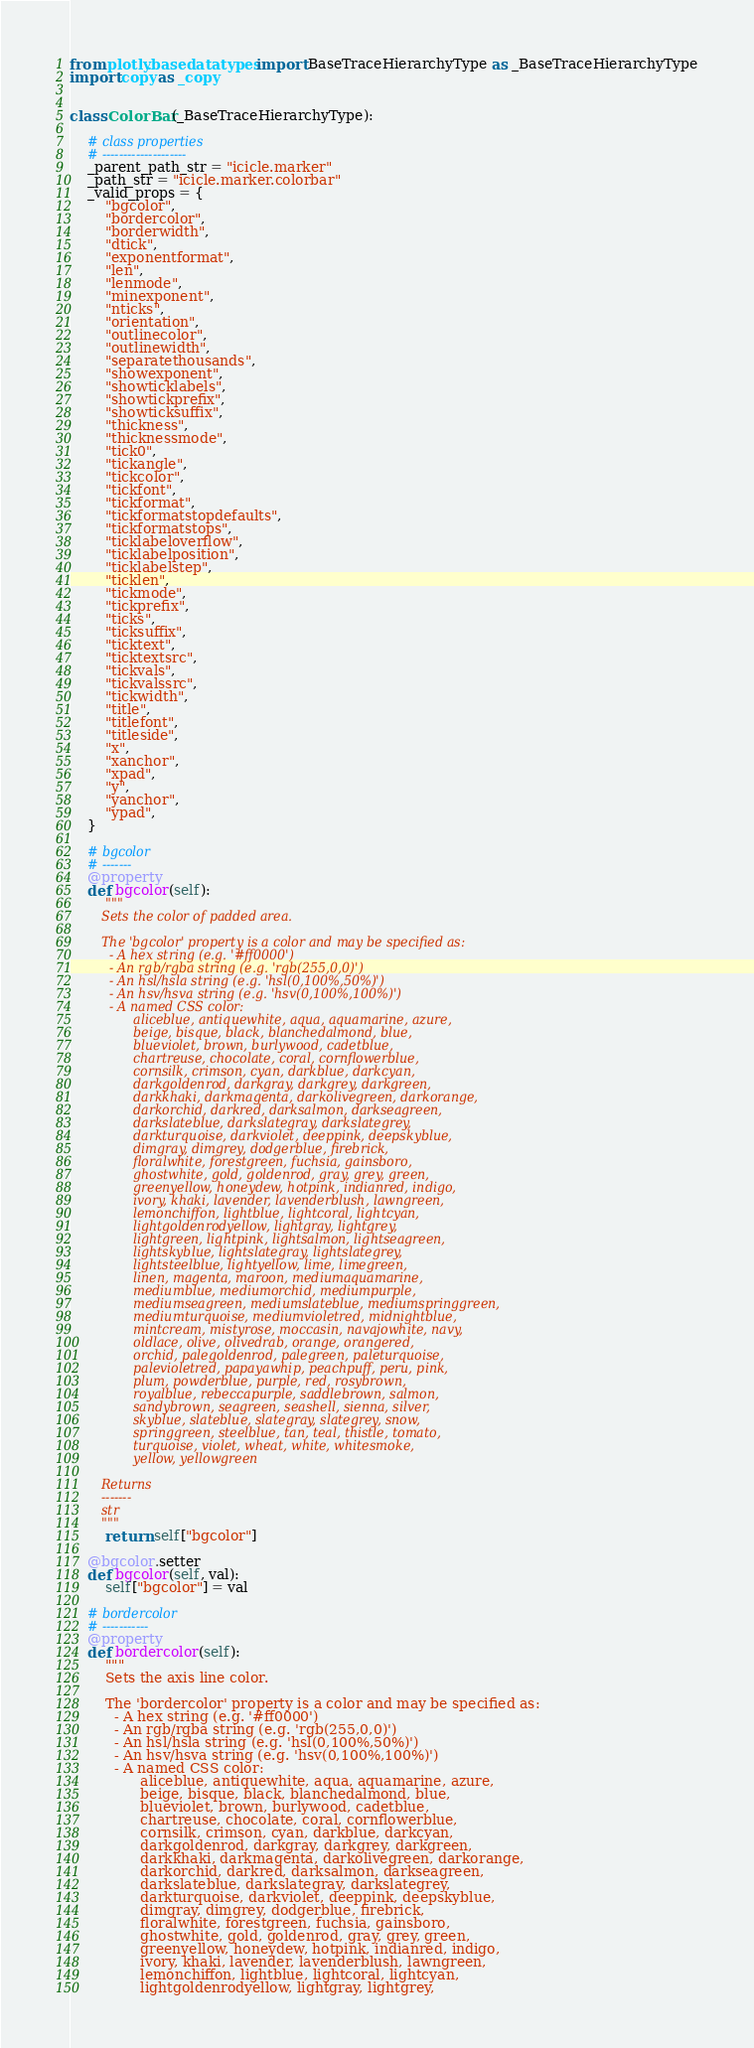Convert code to text. <code><loc_0><loc_0><loc_500><loc_500><_Python_>from plotly.basedatatypes import BaseTraceHierarchyType as _BaseTraceHierarchyType
import copy as _copy


class ColorBar(_BaseTraceHierarchyType):

    # class properties
    # --------------------
    _parent_path_str = "icicle.marker"
    _path_str = "icicle.marker.colorbar"
    _valid_props = {
        "bgcolor",
        "bordercolor",
        "borderwidth",
        "dtick",
        "exponentformat",
        "len",
        "lenmode",
        "minexponent",
        "nticks",
        "orientation",
        "outlinecolor",
        "outlinewidth",
        "separatethousands",
        "showexponent",
        "showticklabels",
        "showtickprefix",
        "showticksuffix",
        "thickness",
        "thicknessmode",
        "tick0",
        "tickangle",
        "tickcolor",
        "tickfont",
        "tickformat",
        "tickformatstopdefaults",
        "tickformatstops",
        "ticklabeloverflow",
        "ticklabelposition",
        "ticklabelstep",
        "ticklen",
        "tickmode",
        "tickprefix",
        "ticks",
        "ticksuffix",
        "ticktext",
        "ticktextsrc",
        "tickvals",
        "tickvalssrc",
        "tickwidth",
        "title",
        "titlefont",
        "titleside",
        "x",
        "xanchor",
        "xpad",
        "y",
        "yanchor",
        "ypad",
    }

    # bgcolor
    # -------
    @property
    def bgcolor(self):
        """
        Sets the color of padded area.

        The 'bgcolor' property is a color and may be specified as:
          - A hex string (e.g. '#ff0000')
          - An rgb/rgba string (e.g. 'rgb(255,0,0)')
          - An hsl/hsla string (e.g. 'hsl(0,100%,50%)')
          - An hsv/hsva string (e.g. 'hsv(0,100%,100%)')
          - A named CSS color:
                aliceblue, antiquewhite, aqua, aquamarine, azure,
                beige, bisque, black, blanchedalmond, blue,
                blueviolet, brown, burlywood, cadetblue,
                chartreuse, chocolate, coral, cornflowerblue,
                cornsilk, crimson, cyan, darkblue, darkcyan,
                darkgoldenrod, darkgray, darkgrey, darkgreen,
                darkkhaki, darkmagenta, darkolivegreen, darkorange,
                darkorchid, darkred, darksalmon, darkseagreen,
                darkslateblue, darkslategray, darkslategrey,
                darkturquoise, darkviolet, deeppink, deepskyblue,
                dimgray, dimgrey, dodgerblue, firebrick,
                floralwhite, forestgreen, fuchsia, gainsboro,
                ghostwhite, gold, goldenrod, gray, grey, green,
                greenyellow, honeydew, hotpink, indianred, indigo,
                ivory, khaki, lavender, lavenderblush, lawngreen,
                lemonchiffon, lightblue, lightcoral, lightcyan,
                lightgoldenrodyellow, lightgray, lightgrey,
                lightgreen, lightpink, lightsalmon, lightseagreen,
                lightskyblue, lightslategray, lightslategrey,
                lightsteelblue, lightyellow, lime, limegreen,
                linen, magenta, maroon, mediumaquamarine,
                mediumblue, mediumorchid, mediumpurple,
                mediumseagreen, mediumslateblue, mediumspringgreen,
                mediumturquoise, mediumvioletred, midnightblue,
                mintcream, mistyrose, moccasin, navajowhite, navy,
                oldlace, olive, olivedrab, orange, orangered,
                orchid, palegoldenrod, palegreen, paleturquoise,
                palevioletred, papayawhip, peachpuff, peru, pink,
                plum, powderblue, purple, red, rosybrown,
                royalblue, rebeccapurple, saddlebrown, salmon,
                sandybrown, seagreen, seashell, sienna, silver,
                skyblue, slateblue, slategray, slategrey, snow,
                springgreen, steelblue, tan, teal, thistle, tomato,
                turquoise, violet, wheat, white, whitesmoke,
                yellow, yellowgreen

        Returns
        -------
        str
        """
        return self["bgcolor"]

    @bgcolor.setter
    def bgcolor(self, val):
        self["bgcolor"] = val

    # bordercolor
    # -----------
    @property
    def bordercolor(self):
        """
        Sets the axis line color.

        The 'bordercolor' property is a color and may be specified as:
          - A hex string (e.g. '#ff0000')
          - An rgb/rgba string (e.g. 'rgb(255,0,0)')
          - An hsl/hsla string (e.g. 'hsl(0,100%,50%)')
          - An hsv/hsva string (e.g. 'hsv(0,100%,100%)')
          - A named CSS color:
                aliceblue, antiquewhite, aqua, aquamarine, azure,
                beige, bisque, black, blanchedalmond, blue,
                blueviolet, brown, burlywood, cadetblue,
                chartreuse, chocolate, coral, cornflowerblue,
                cornsilk, crimson, cyan, darkblue, darkcyan,
                darkgoldenrod, darkgray, darkgrey, darkgreen,
                darkkhaki, darkmagenta, darkolivegreen, darkorange,
                darkorchid, darkred, darksalmon, darkseagreen,
                darkslateblue, darkslategray, darkslategrey,
                darkturquoise, darkviolet, deeppink, deepskyblue,
                dimgray, dimgrey, dodgerblue, firebrick,
                floralwhite, forestgreen, fuchsia, gainsboro,
                ghostwhite, gold, goldenrod, gray, grey, green,
                greenyellow, honeydew, hotpink, indianred, indigo,
                ivory, khaki, lavender, lavenderblush, lawngreen,
                lemonchiffon, lightblue, lightcoral, lightcyan,
                lightgoldenrodyellow, lightgray, lightgrey,</code> 